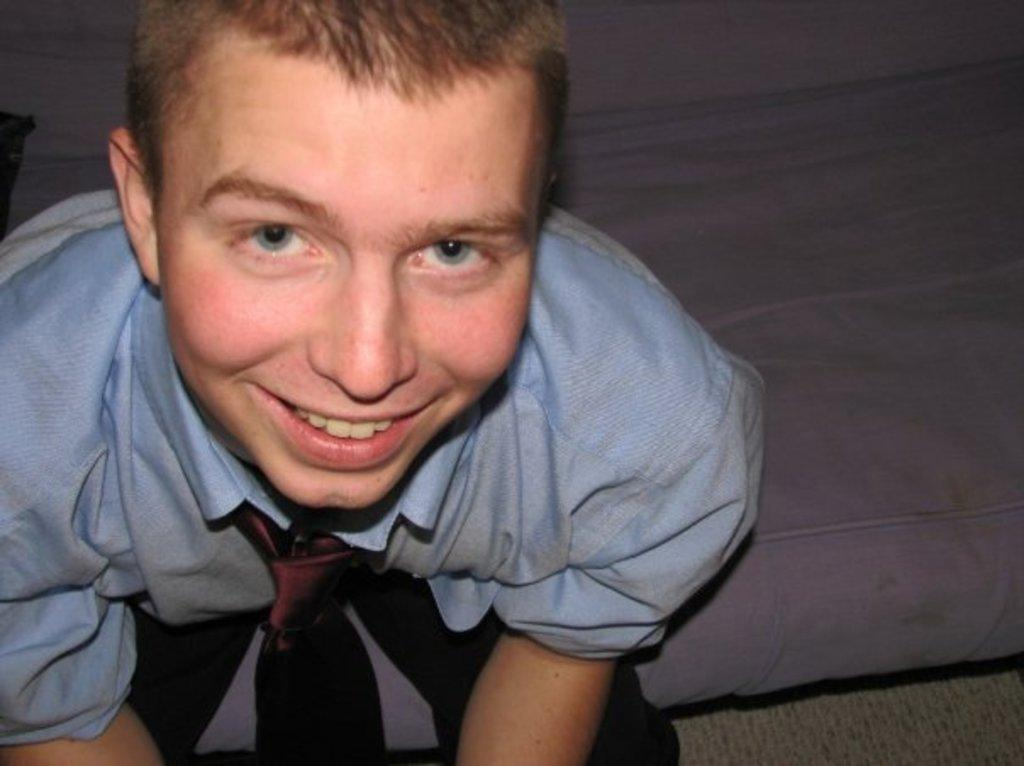What is present in the image? There is a person in the image. Can you describe the person's expression? The person is smiling. What organization does the person belong to in the image? There is no information about any organization in the image; it only shows a person smiling. What type of eye makeup is the person wearing in the image? There is no information about the person's eye makeup in the image; it only shows a person smiling. 